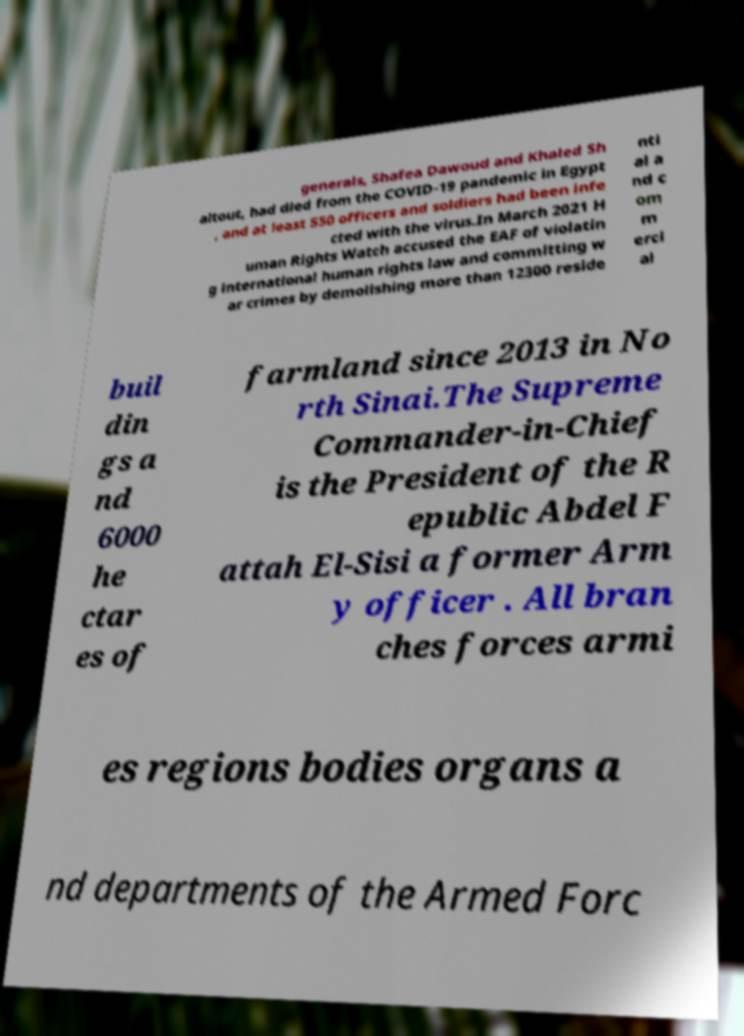Could you extract and type out the text from this image? generals, Shafea Dawoud and Khaled Sh altout, had died from the COVID-19 pandemic in Egypt , and at least 550 officers and soldiers had been infe cted with the virus.In March 2021 H uman Rights Watch accused the EAF of violatin g international human rights law and committing w ar crimes by demolishing more than 12300 reside nti al a nd c om m erci al buil din gs a nd 6000 he ctar es of farmland since 2013 in No rth Sinai.The Supreme Commander-in-Chief is the President of the R epublic Abdel F attah El-Sisi a former Arm y officer . All bran ches forces armi es regions bodies organs a nd departments of the Armed Forc 